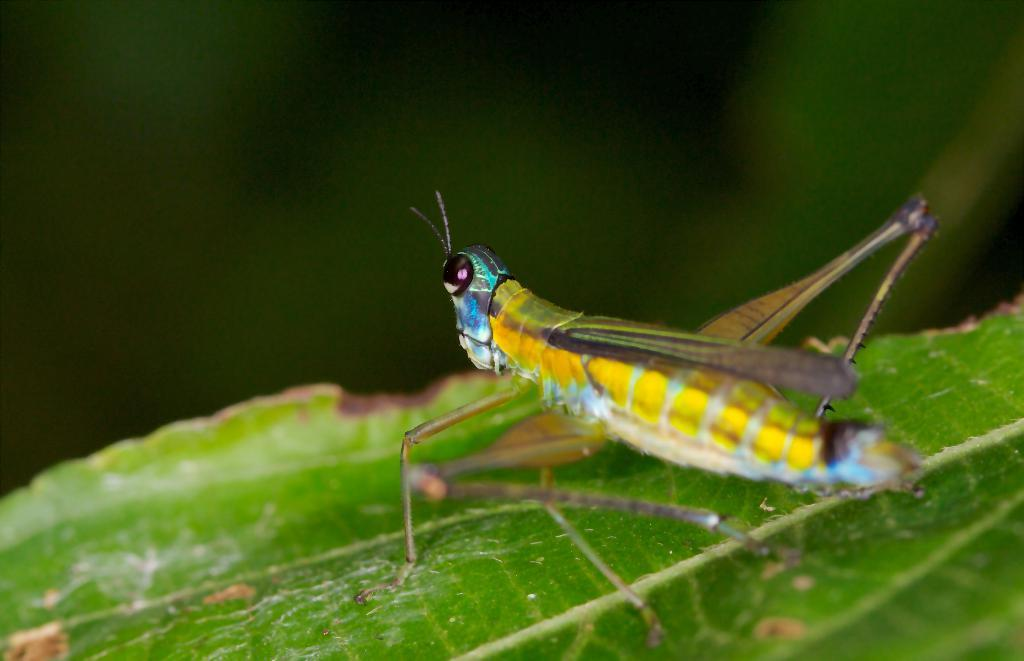What is present on the leaf in the image? There is an insect on the leaf in the image. Can you describe the insect's location on the leaf? The insect is on the leaf in the image. What type of prose is being recited by the insect in the image? There is no indication in the image that the insect is reciting any prose. 